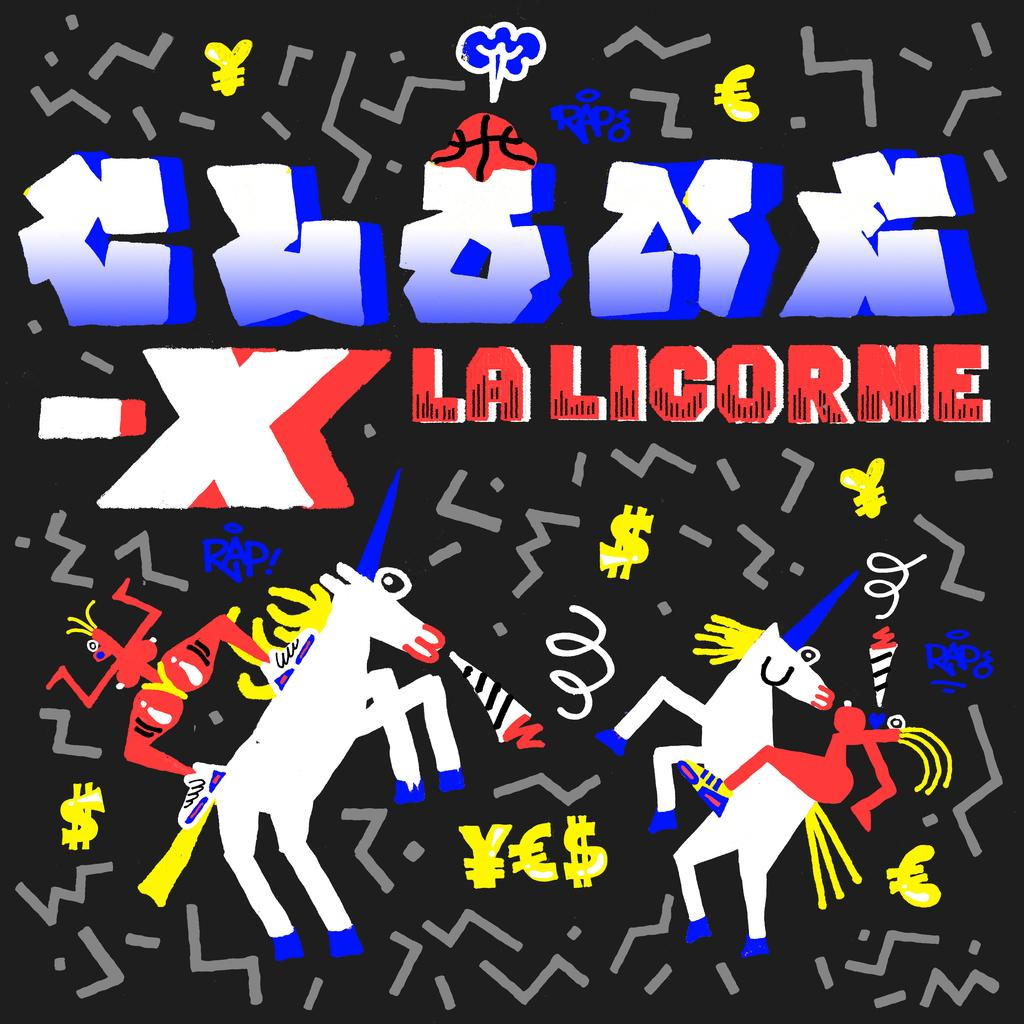What is the color of the poster in the image? The poster is black. What can be seen on the poster besides its color? There are figures and text on the poster. Where is the desk located in the image? There is no desk present in the image. What type of spring can be seen on the poster? There is no spring present on the poster; it features figures and text. 